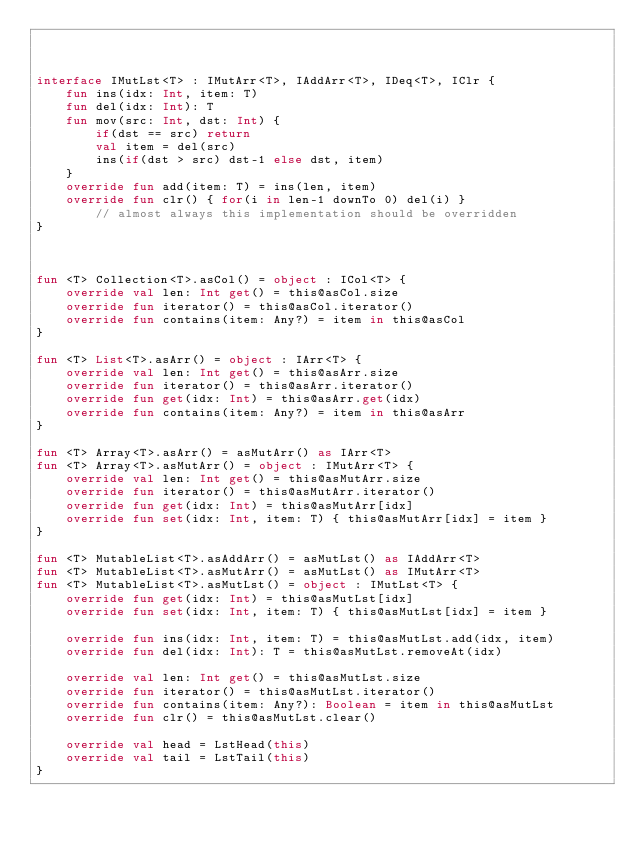Convert code to text. <code><loc_0><loc_0><loc_500><loc_500><_Kotlin_>


interface IMutLst<T> : IMutArr<T>, IAddArr<T>, IDeq<T>, IClr {
    fun ins(idx: Int, item: T)
    fun del(idx: Int): T
    fun mov(src: Int, dst: Int) {
        if(dst == src) return
        val item = del(src)
        ins(if(dst > src) dst-1 else dst, item)
    }
    override fun add(item: T) = ins(len, item)
    override fun clr() { for(i in len-1 downTo 0) del(i) }
        // almost always this implementation should be overridden
}



fun <T> Collection<T>.asCol() = object : ICol<T> {
    override val len: Int get() = this@asCol.size
    override fun iterator() = this@asCol.iterator()
    override fun contains(item: Any?) = item in this@asCol
}

fun <T> List<T>.asArr() = object : IArr<T> {
    override val len: Int get() = this@asArr.size
    override fun iterator() = this@asArr.iterator()
    override fun get(idx: Int) = this@asArr.get(idx)
    override fun contains(item: Any?) = item in this@asArr
}

fun <T> Array<T>.asArr() = asMutArr() as IArr<T>
fun <T> Array<T>.asMutArr() = object : IMutArr<T> {
    override val len: Int get() = this@asMutArr.size
    override fun iterator() = this@asMutArr.iterator()
    override fun get(idx: Int) = this@asMutArr[idx]
    override fun set(idx: Int, item: T) { this@asMutArr[idx] = item }
}

fun <T> MutableList<T>.asAddArr() = asMutLst() as IAddArr<T>
fun <T> MutableList<T>.asMutArr() = asMutLst() as IMutArr<T>
fun <T> MutableList<T>.asMutLst() = object : IMutLst<T> {
    override fun get(idx: Int) = this@asMutLst[idx]
    override fun set(idx: Int, item: T) { this@asMutLst[idx] = item }

    override fun ins(idx: Int, item: T) = this@asMutLst.add(idx, item)
    override fun del(idx: Int): T = this@asMutLst.removeAt(idx)

    override val len: Int get() = this@asMutLst.size
    override fun iterator() = this@asMutLst.iterator()
    override fun contains(item: Any?): Boolean = item in this@asMutLst
    override fun clr() = this@asMutLst.clear()

    override val head = LstHead(this)
    override val tail = LstTail(this)
}
</code> 